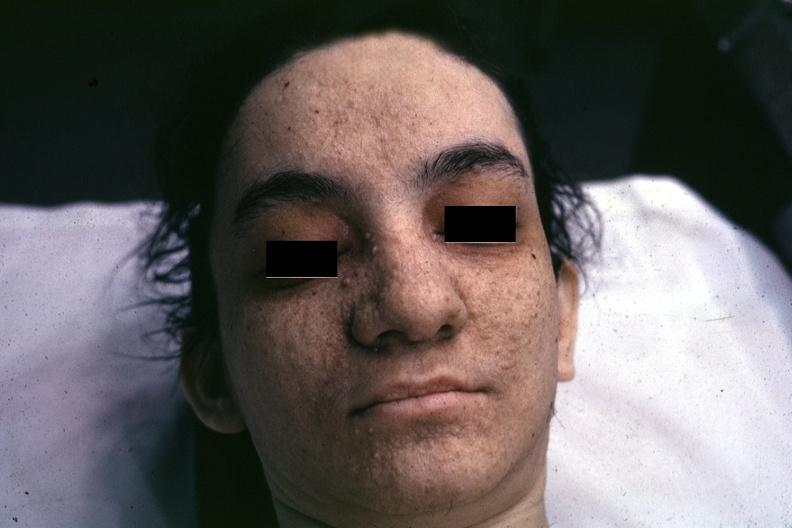does this image show very good example associated with tuberous sclerosis?
Answer the question using a single word or phrase. Yes 